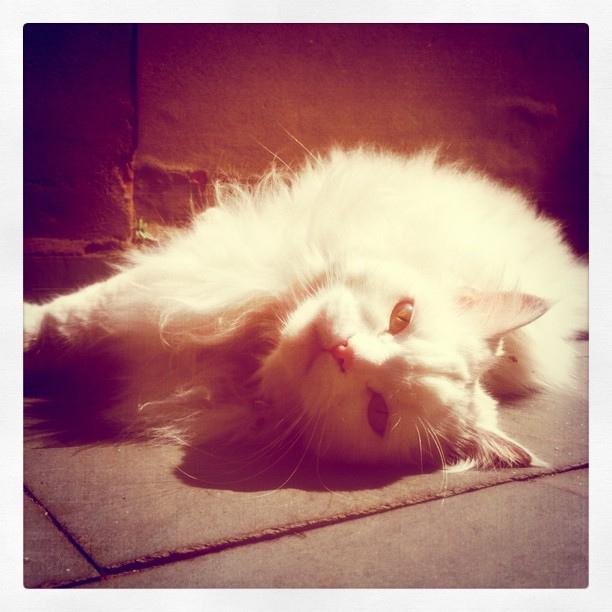Is the kitty lying down?
Concise answer only. Yes. Is the kitty looking into or away from the camera?
Quick response, please. Into. Is the kitty asleep?
Keep it brief. No. 